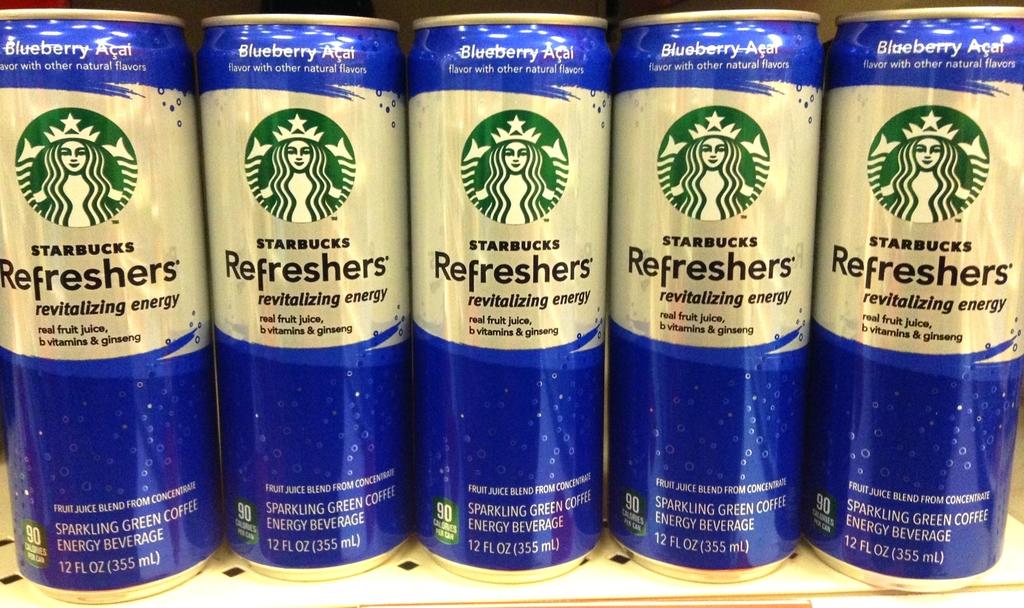What flavour is this drink?
Your response must be concise. Blueberry acai. 